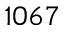<formula> <loc_0><loc_0><loc_500><loc_500>1 0 6 7</formula> 